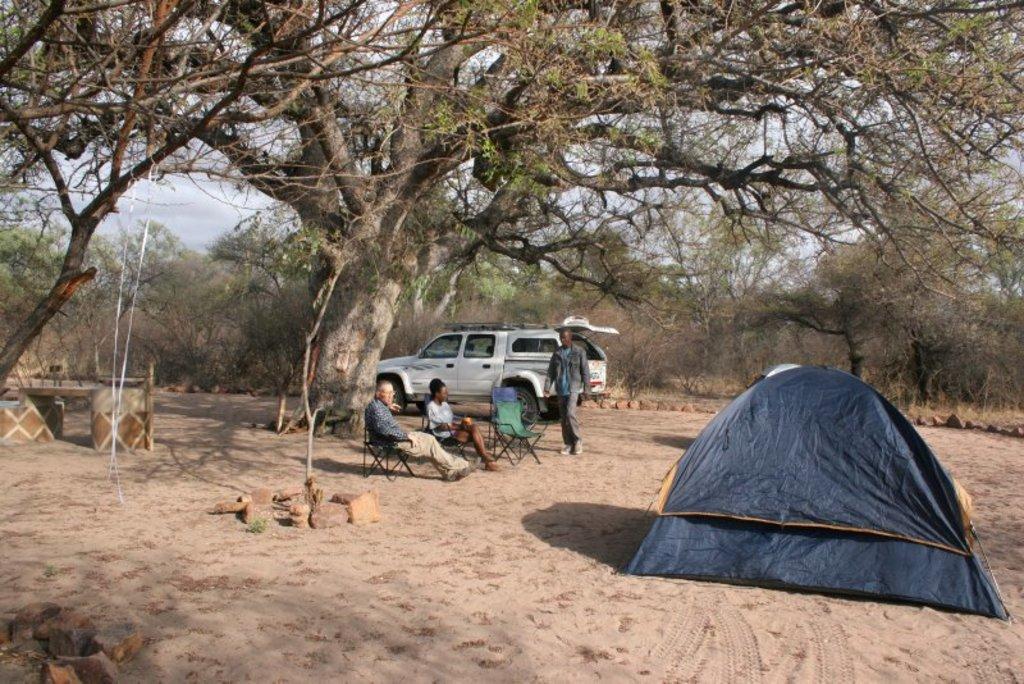Please provide a concise description of this image. In the center of the image we can see two people sitting on the chair and there is a man walking. On the right there is a tent. In the background we can see a car, trees and sky. 